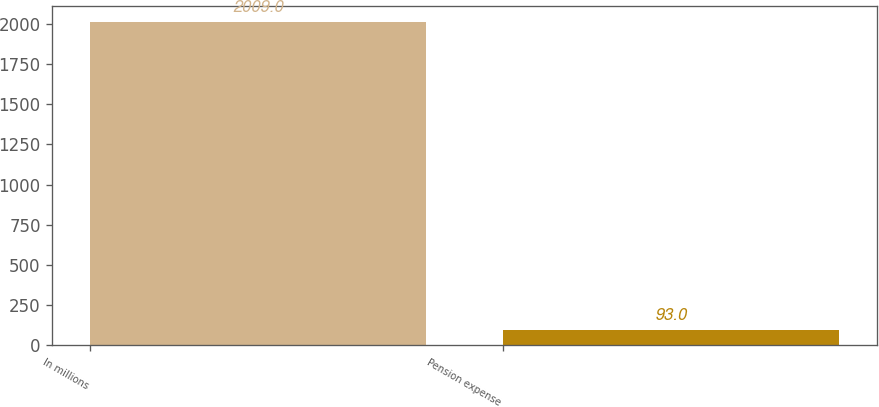Convert chart to OTSL. <chart><loc_0><loc_0><loc_500><loc_500><bar_chart><fcel>In millions<fcel>Pension expense<nl><fcel>2009<fcel>93<nl></chart> 